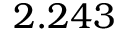<formula> <loc_0><loc_0><loc_500><loc_500>2 . 2 4 3</formula> 